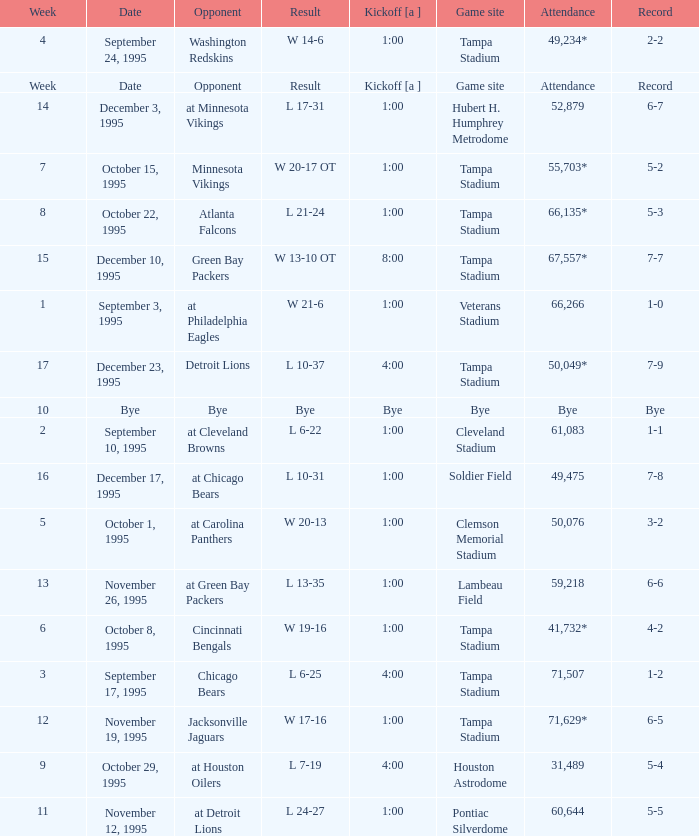Who did the Tampa Bay Buccaneers play on december 23, 1995? Detroit Lions. 